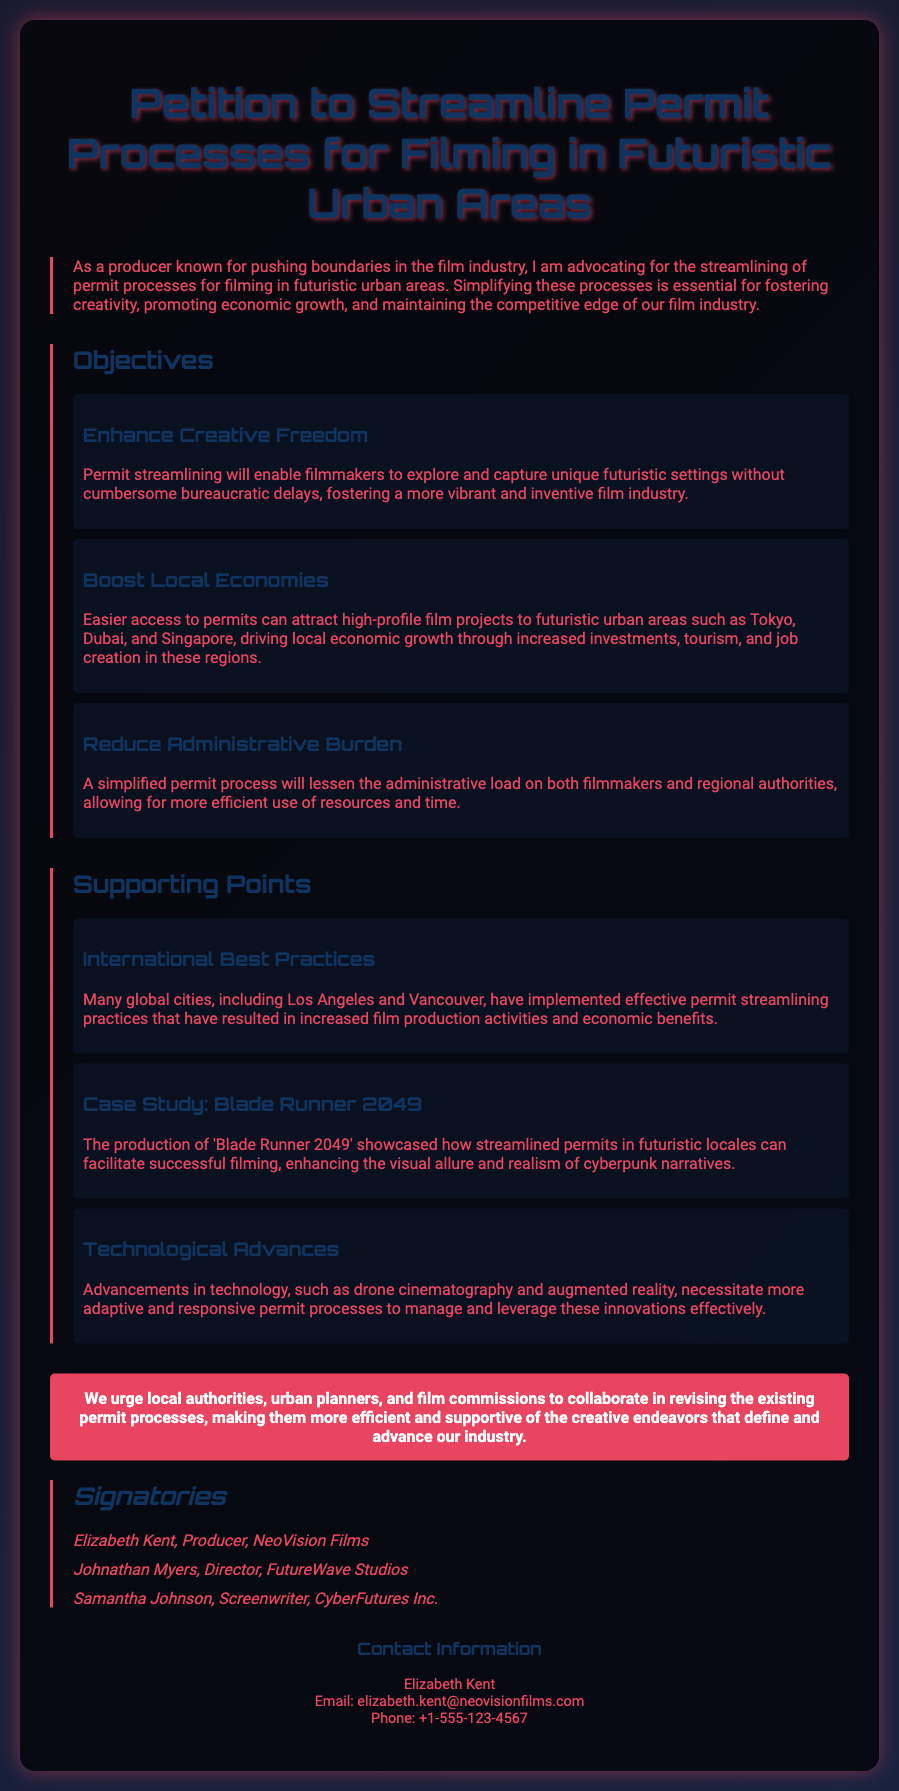What is the title of the petition? The title of the petition is clearly stated at the top of the document.
Answer: Petition to Streamline Permit Processes for Filming in Futuristic Urban Areas Who is the producer advocating for the petition? The name of the producer advocating is mentioned in the introduction.
Answer: Elizabeth Kent What is one objective of the petition? The document lists specific objectives in the Objectives section.
Answer: Enhance Creative Freedom What city is mentioned as a potential location for filming? The document refers to specific urban areas in the Boost Local Economies objective.
Answer: Tokyo What is a technological advancement mentioned in the Supporting Points? The Supporting Points section lists advancements relevant to permit processes.
Answer: Drone cinematography How many signatories are listed in the document? The number of signatories can be counted in the Signatories section.
Answer: Three What film is referenced as a case study? The document specifically mentions a film that exemplifies successful filming in futuristic locales.
Answer: Blade Runner 2049 What is the main call to action in the petition? The call to action is detailed in the CTA section of the petition.
Answer: Revise the existing permit processes What is the email address of the contact person? The email address is provided in the Contact Information section.
Answer: elizabeth.kent@neovisionfilms.com 